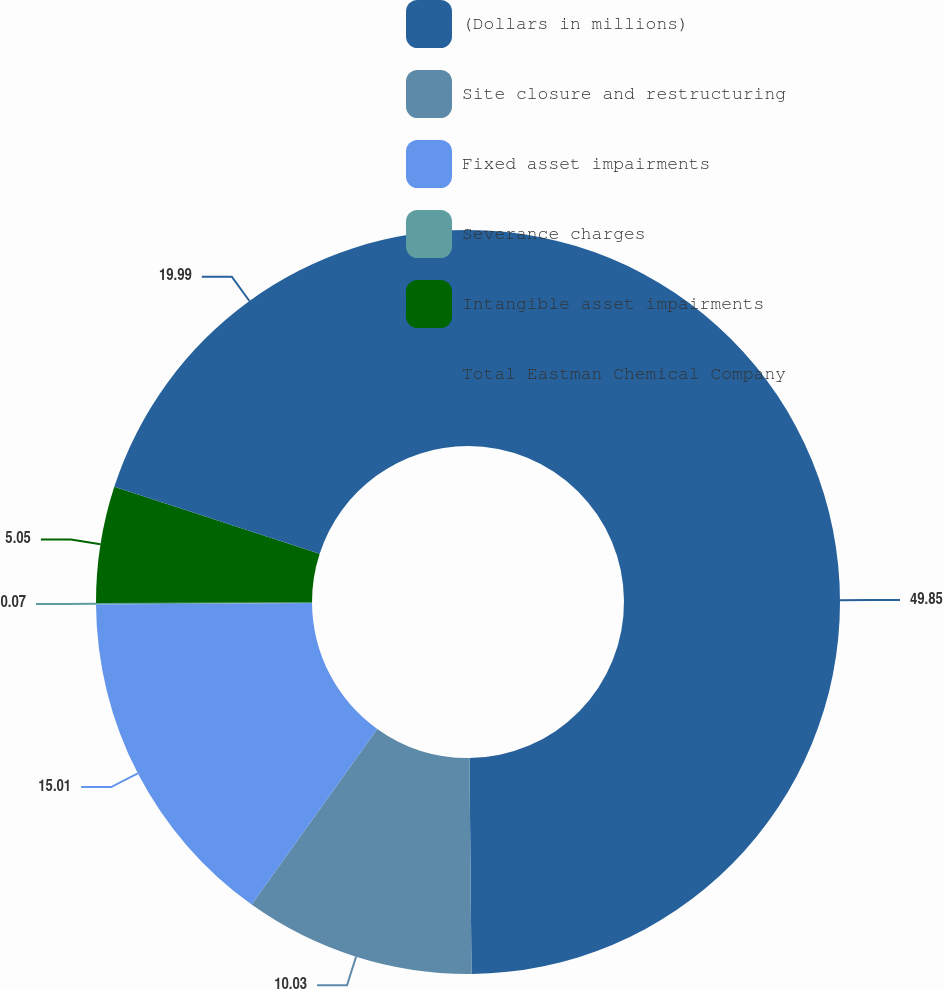Convert chart to OTSL. <chart><loc_0><loc_0><loc_500><loc_500><pie_chart><fcel>(Dollars in millions)<fcel>Site closure and restructuring<fcel>Fixed asset impairments<fcel>Severance charges<fcel>Intangible asset impairments<fcel>Total Eastman Chemical Company<nl><fcel>49.85%<fcel>10.03%<fcel>15.01%<fcel>0.07%<fcel>5.05%<fcel>19.99%<nl></chart> 